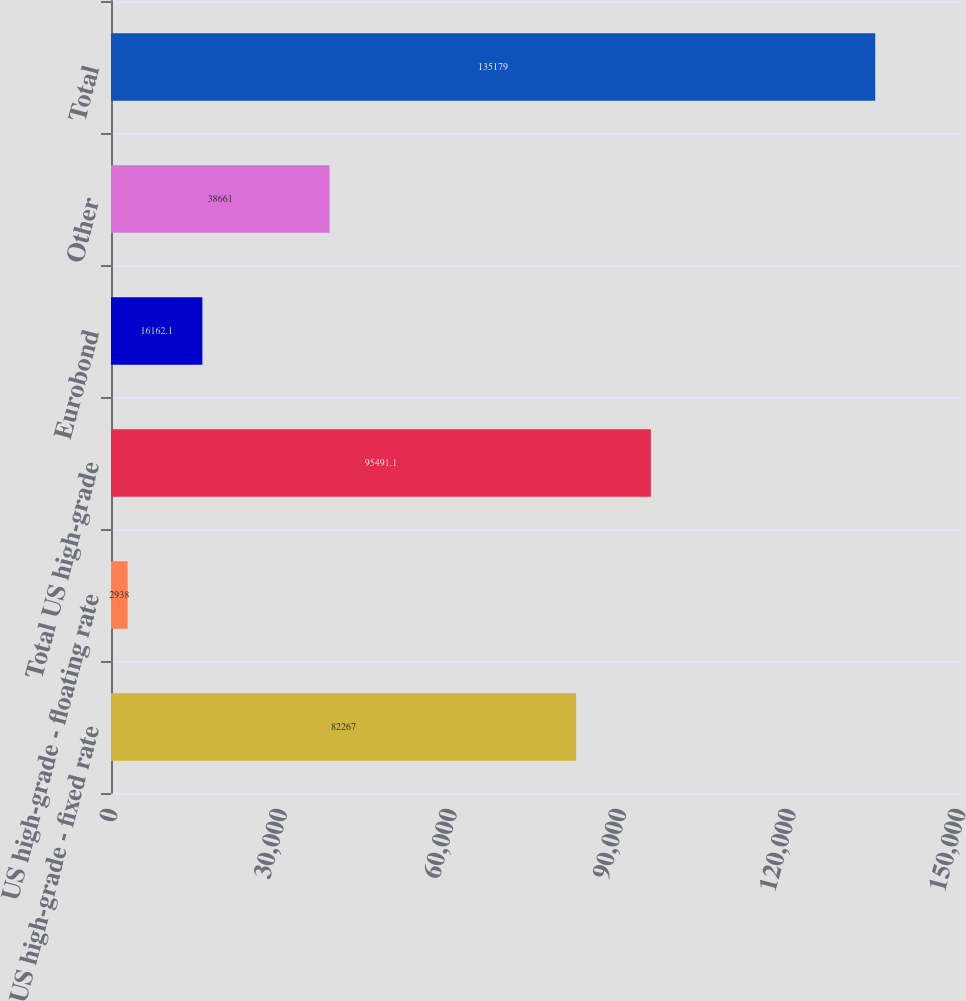Convert chart. <chart><loc_0><loc_0><loc_500><loc_500><bar_chart><fcel>US high-grade - fixed rate<fcel>US high-grade - floating rate<fcel>Total US high-grade<fcel>Eurobond<fcel>Other<fcel>Total<nl><fcel>82267<fcel>2938<fcel>95491.1<fcel>16162.1<fcel>38661<fcel>135179<nl></chart> 